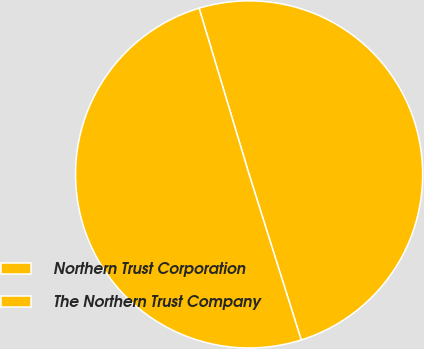Convert chart to OTSL. <chart><loc_0><loc_0><loc_500><loc_500><pie_chart><fcel>Northern Trust Corporation<fcel>The Northern Trust Company<nl><fcel>49.8%<fcel>50.2%<nl></chart> 